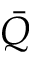Convert formula to latex. <formula><loc_0><loc_0><loc_500><loc_500>\bar { Q }</formula> 